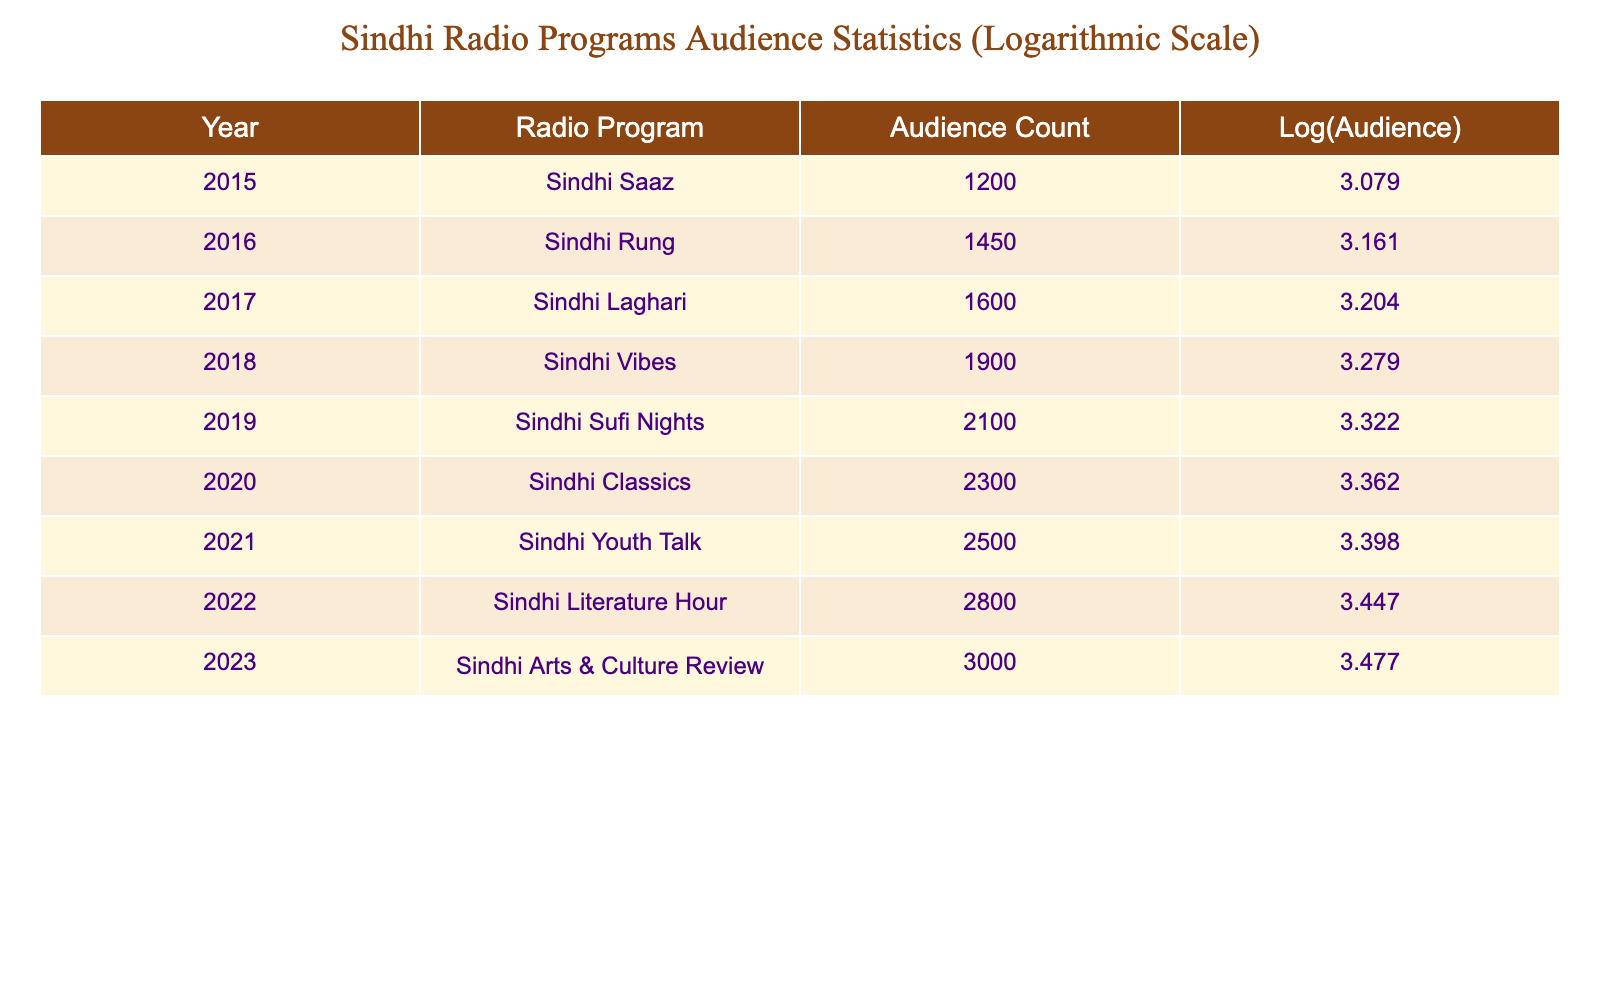What was the audience count for the Sindhi Vibes program in 2018? According to the table, the audience count for the Sindhi Vibes program in 2018 is directly listed as 1900.
Answer: 1900 How many more audience members did the Sindhi Arts & Culture Review have compared to Sindhi Saaz? The Sindhi Arts & Culture Review in 2023 had an audience count of 3000, while Sindhi Saaz in 2015 had 1200. The difference is 3000 - 1200 = 1800.
Answer: 1800 Was the audience count for Sindhi Youth Talk in 2021 greater than that for Sindhi Classics in 2020? The audience count for Sindhi Youth Talk in 2021 is 2500, while for Sindhi Classics in 2020 it was 2300. Since 2500 is greater than 2300, the answer is yes.
Answer: Yes What is the average audience count from 2015 to 2023? To find the average, sum the audience counts (1200 + 1450 + 1600 + 1900 + 2100 + 2300 + 2500 + 2800 + 3000 = 18650) and divide by the number of years (9). Therefore, the average is 18650 / 9 ≈ 2072.22.
Answer: 2072.22 Did Sindhi Rung have a higher audience count than Sindhi Laghari? The audience count for Sindhi Rung in 2016 is 1450 and for Sindhi Laghari in 2017, it is 1600. Since 1450 is less than 1600, the answer is no.
Answer: No What was the total audience count for the Sindhi Sufi Nights and Sindhi Literature Hour programs combined? The audience count for Sindhi Sufi Nights in 2019 is 2100 and for Sindhi Literature Hour in 2022 is 2800. Adding these together gives 2100 + 2800 = 4900.
Answer: 4900 Which program in 2022 had the largest audience count, and what was that count? The program in 2022 is the Sindhi Literature Hour with an audience count of 2800. This is the highest count listed for that year.
Answer: 2800 How much did the audience count grow from 2015 to 2023? The audience count increased from 1200 in 2015 to 3000 in 2023. The growth can be calculated by subtracting: 3000 - 1200 = 1800.
Answer: 1800 In 2016, what was the logarithmic value of the audience count for the Sindhi Rung program? The audience count for Sindhi Rung in 2016 is 1450. The logarithmic value calculated is log10(1450) ≈ 3.160.
Answer: 3.160 